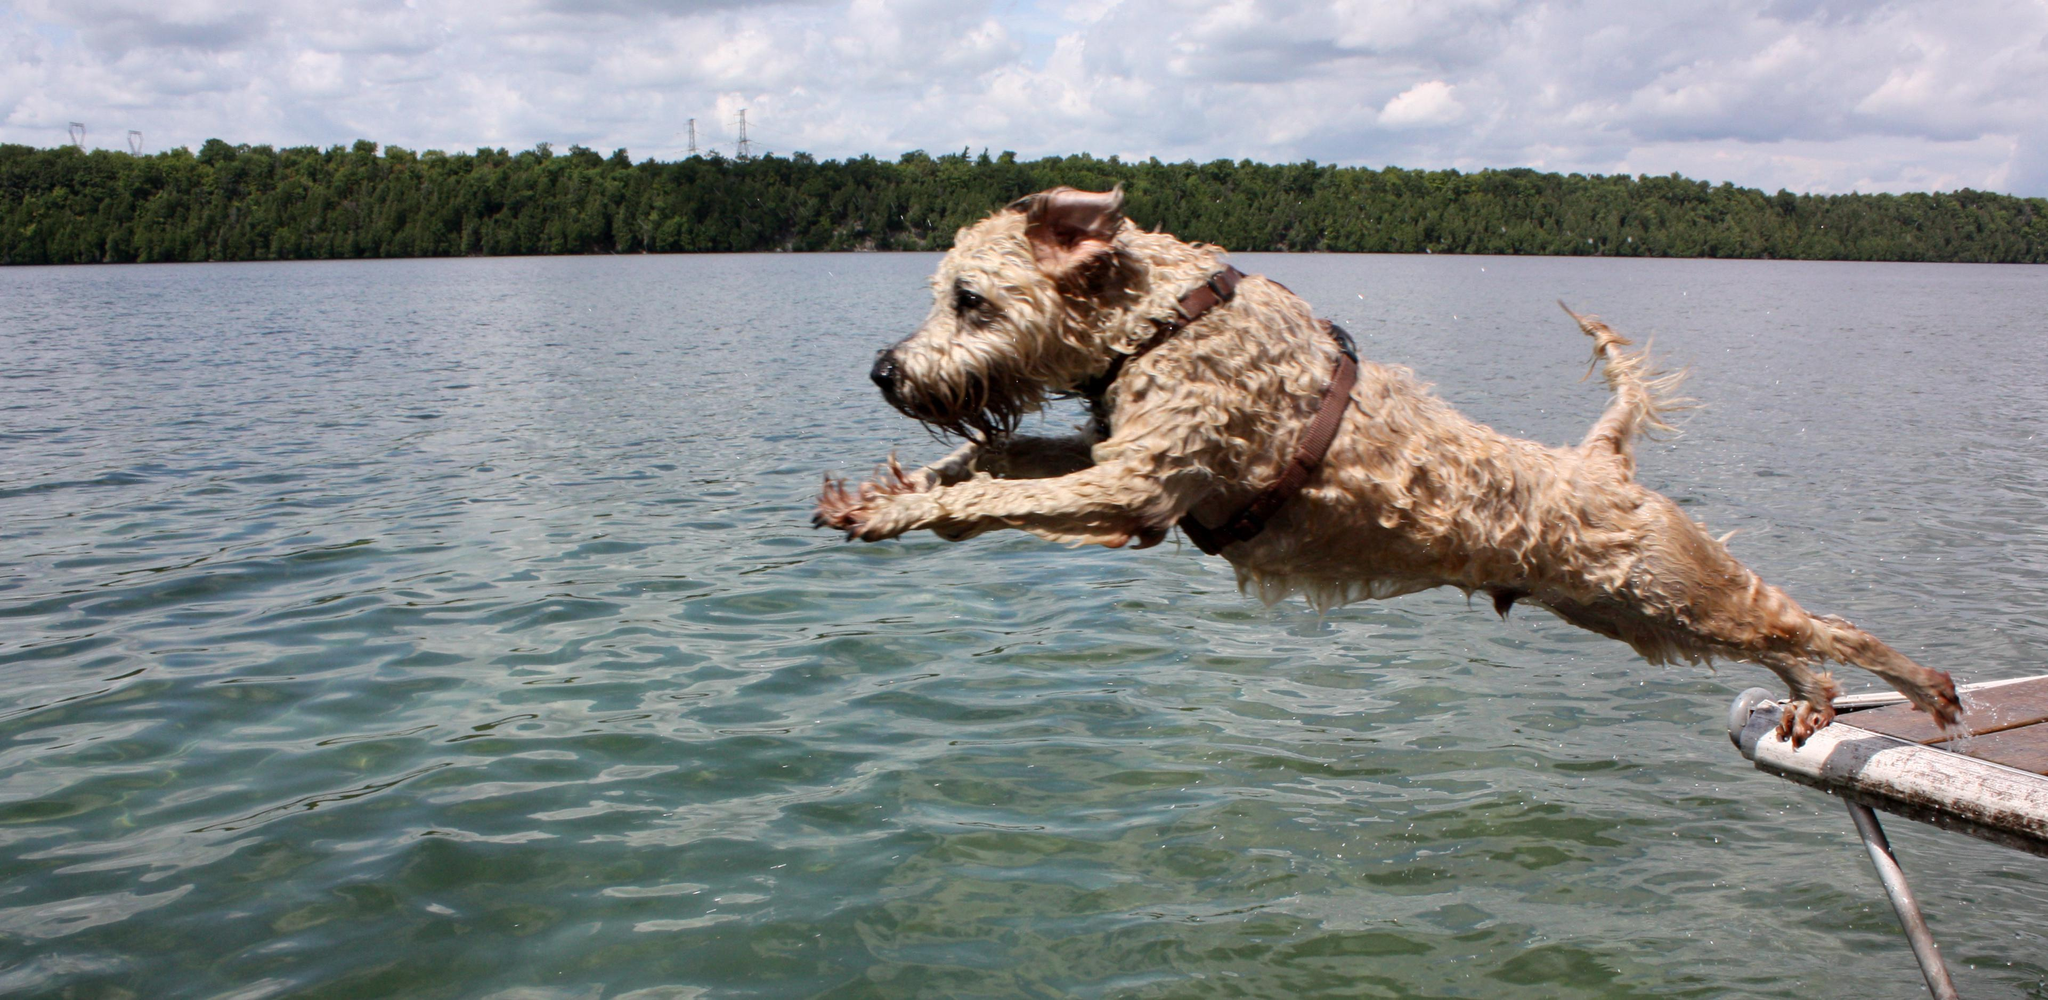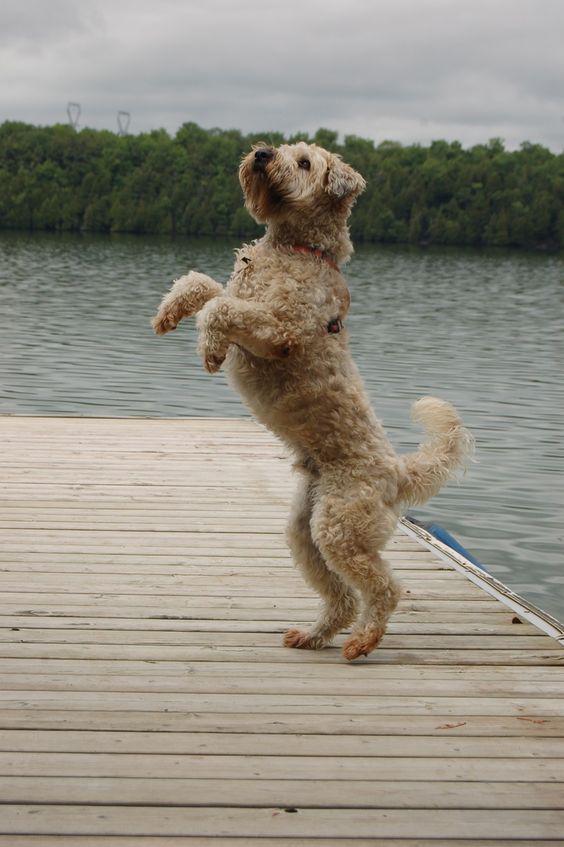The first image is the image on the left, the second image is the image on the right. Analyze the images presented: Is the assertion "At least one image shows a body of water behind one dog." valid? Answer yes or no. Yes. The first image is the image on the left, the second image is the image on the right. For the images displayed, is the sentence "An image contains a small dog with water in the background." factually correct? Answer yes or no. Yes. 